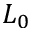<formula> <loc_0><loc_0><loc_500><loc_500>L _ { 0 }</formula> 